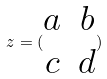Convert formula to latex. <formula><loc_0><loc_0><loc_500><loc_500>z = ( \begin{matrix} a & b \\ c & d \end{matrix} )</formula> 